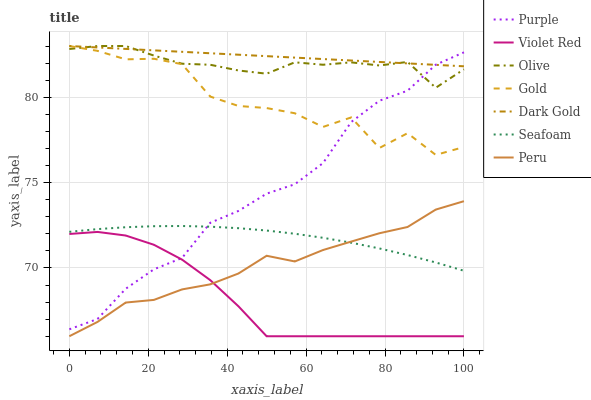Does Violet Red have the minimum area under the curve?
Answer yes or no. Yes. Does Dark Gold have the maximum area under the curve?
Answer yes or no. Yes. Does Gold have the minimum area under the curve?
Answer yes or no. No. Does Gold have the maximum area under the curve?
Answer yes or no. No. Is Dark Gold the smoothest?
Answer yes or no. Yes. Is Gold the roughest?
Answer yes or no. Yes. Is Gold the smoothest?
Answer yes or no. No. Is Dark Gold the roughest?
Answer yes or no. No. Does Gold have the lowest value?
Answer yes or no. No. Does Purple have the highest value?
Answer yes or no. No. Is Violet Red less than Seafoam?
Answer yes or no. Yes. Is Olive greater than Seafoam?
Answer yes or no. Yes. Does Violet Red intersect Seafoam?
Answer yes or no. No. 